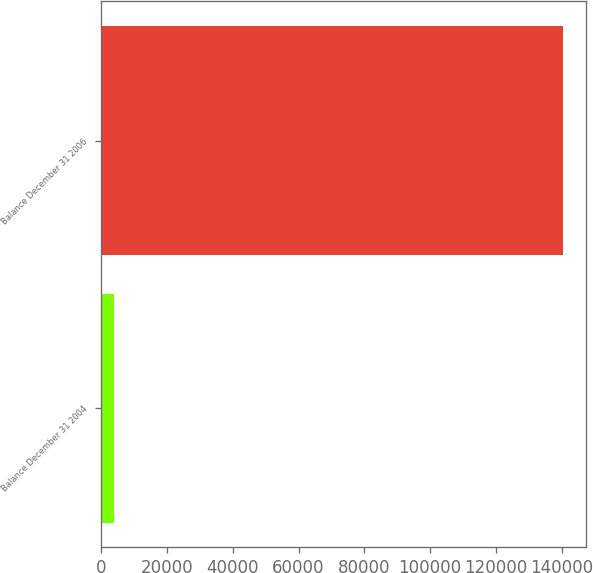Convert chart to OTSL. <chart><loc_0><loc_0><loc_500><loc_500><bar_chart><fcel>Balance December 31 2004<fcel>Balance December 31 2006<nl><fcel>3749<fcel>140509<nl></chart> 